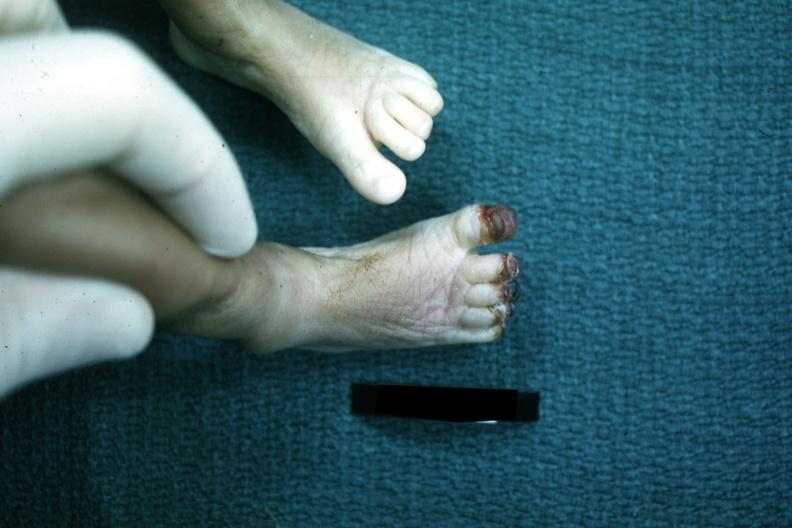s this image present?
Answer the question using a single word or phrase. No 